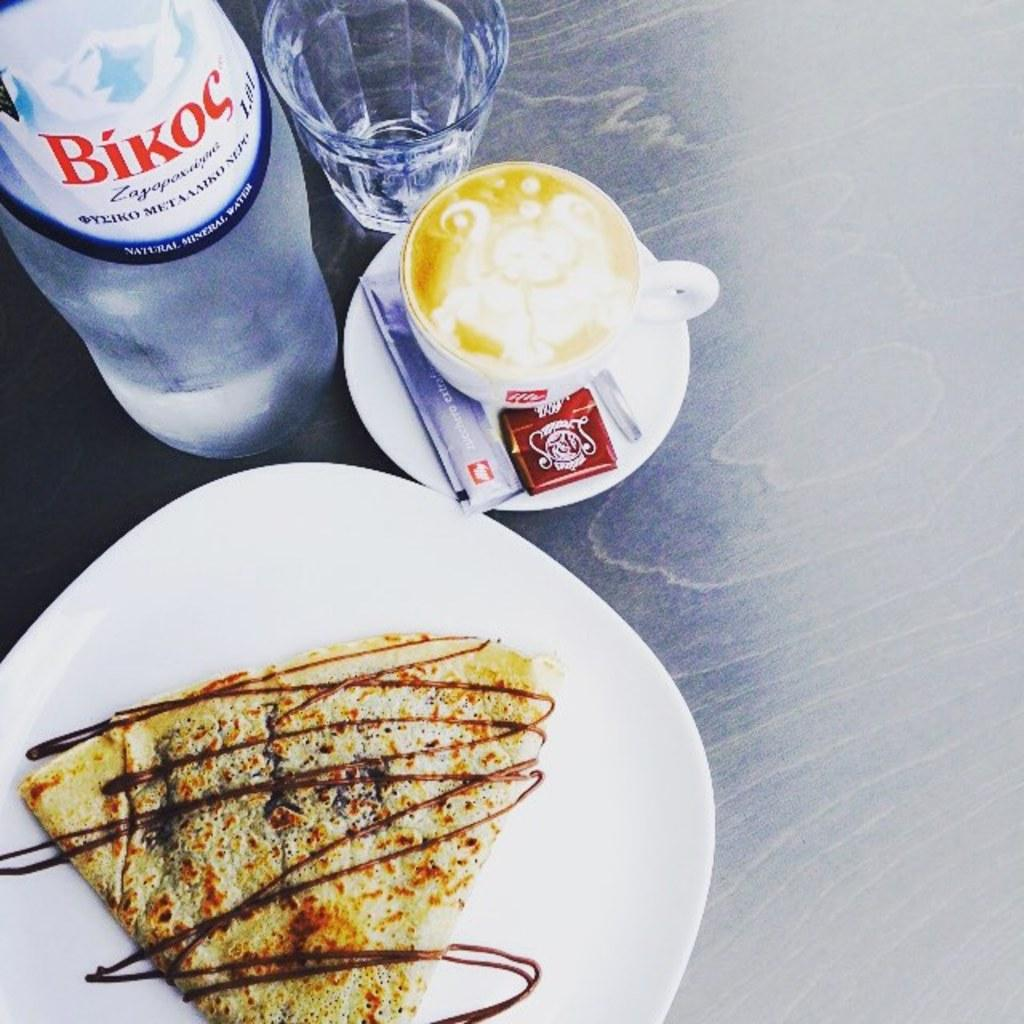<image>
Share a concise interpretation of the image provided. A dessert pancakes sits on a table with a cappuccino and a bottle of Bikoc water. 